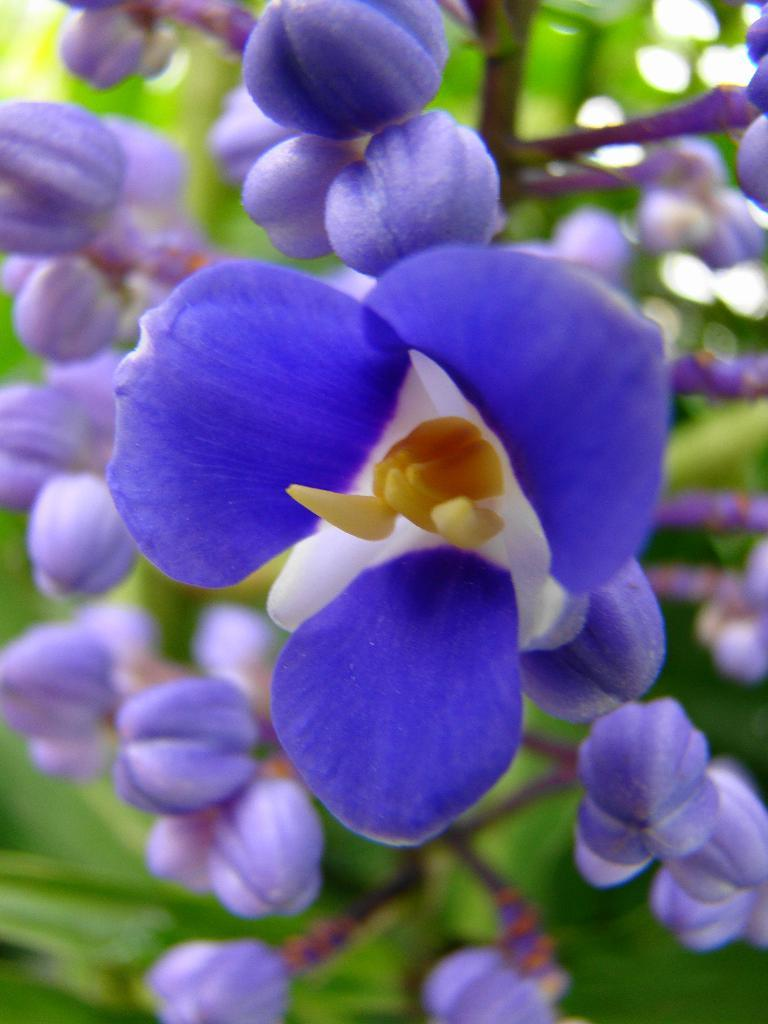What color are the flowers in the image? The flowers in the image are violet color. What type of plant is featured in the image? The plant in the image has violet color flowers. Can you describe the background of the image? The background of the image is blurred. How many ladybugs can be seen on the guitar in the image? There is no guitar or ladybugs present in the image; it features a plant with violet color flowers. 